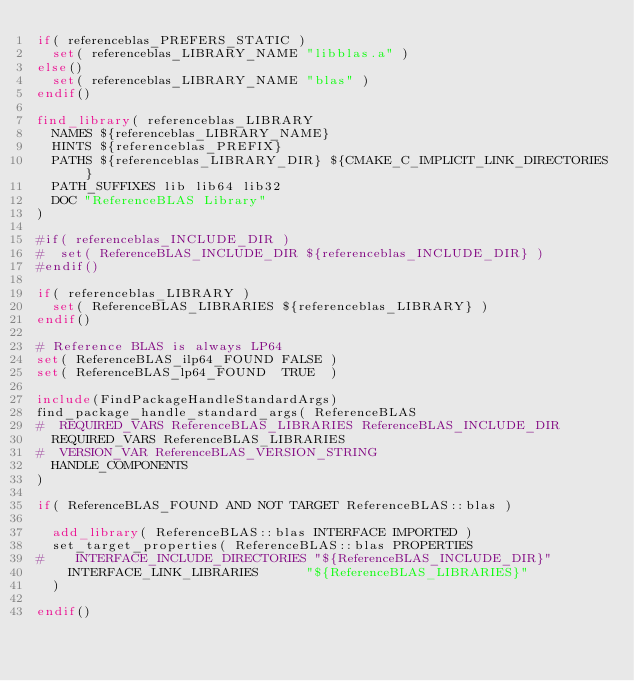<code> <loc_0><loc_0><loc_500><loc_500><_CMake_>if( referenceblas_PREFERS_STATIC )
  set( referenceblas_LIBRARY_NAME "libblas.a" )
else()
  set( referenceblas_LIBRARY_NAME "blas" )
endif()

find_library( referenceblas_LIBRARY
  NAMES ${referenceblas_LIBRARY_NAME}
  HINTS ${referenceblas_PREFIX}
  PATHS ${referenceblas_LIBRARY_DIR} ${CMAKE_C_IMPLICIT_LINK_DIRECTORIES} 
  PATH_SUFFIXES lib lib64 lib32
  DOC "ReferenceBLAS Library"
)

#if( referenceblas_INCLUDE_DIR )
#  set( ReferenceBLAS_INCLUDE_DIR ${referenceblas_INCLUDE_DIR} )
#endif()

if( referenceblas_LIBRARY )
  set( ReferenceBLAS_LIBRARIES ${referenceblas_LIBRARY} )
endif()

# Reference BLAS is always LP64
set( ReferenceBLAS_ilp64_FOUND FALSE )
set( ReferenceBLAS_lp64_FOUND  TRUE  )

include(FindPackageHandleStandardArgs)
find_package_handle_standard_args( ReferenceBLAS
#  REQUIRED_VARS ReferenceBLAS_LIBRARIES ReferenceBLAS_INCLUDE_DIR
  REQUIRED_VARS ReferenceBLAS_LIBRARIES
#  VERSION_VAR ReferenceBLAS_VERSION_STRING
  HANDLE_COMPONENTS
)

if( ReferenceBLAS_FOUND AND NOT TARGET ReferenceBLAS::blas )

  add_library( ReferenceBLAS::blas INTERFACE IMPORTED )
  set_target_properties( ReferenceBLAS::blas PROPERTIES
#    INTERFACE_INCLUDE_DIRECTORIES "${ReferenceBLAS_INCLUDE_DIR}"
    INTERFACE_LINK_LIBRARIES      "${ReferenceBLAS_LIBRARIES}"
  )

endif()

</code> 